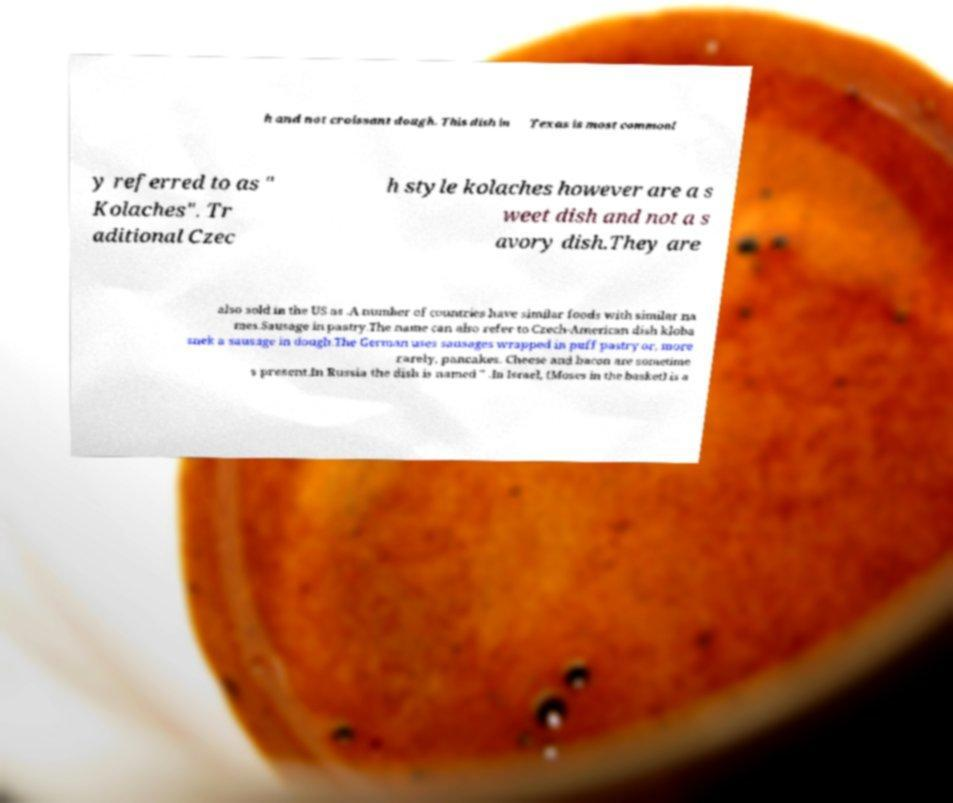What messages or text are displayed in this image? I need them in a readable, typed format. h and not croissant dough. This dish in Texas is most commonl y referred to as " Kolaches". Tr aditional Czec h style kolaches however are a s weet dish and not a s avory dish.They are also sold in the US as .A number of countries have similar foods with similar na mes.Sausage in pastry.The name can also refer to Czech-American dish kloba snek a sausage in dough.The German uses sausages wrapped in puff pastry or, more rarely, pancakes. Cheese and bacon are sometime s present.In Russia the dish is named " .In Israel, (Moses in the basket) is a 